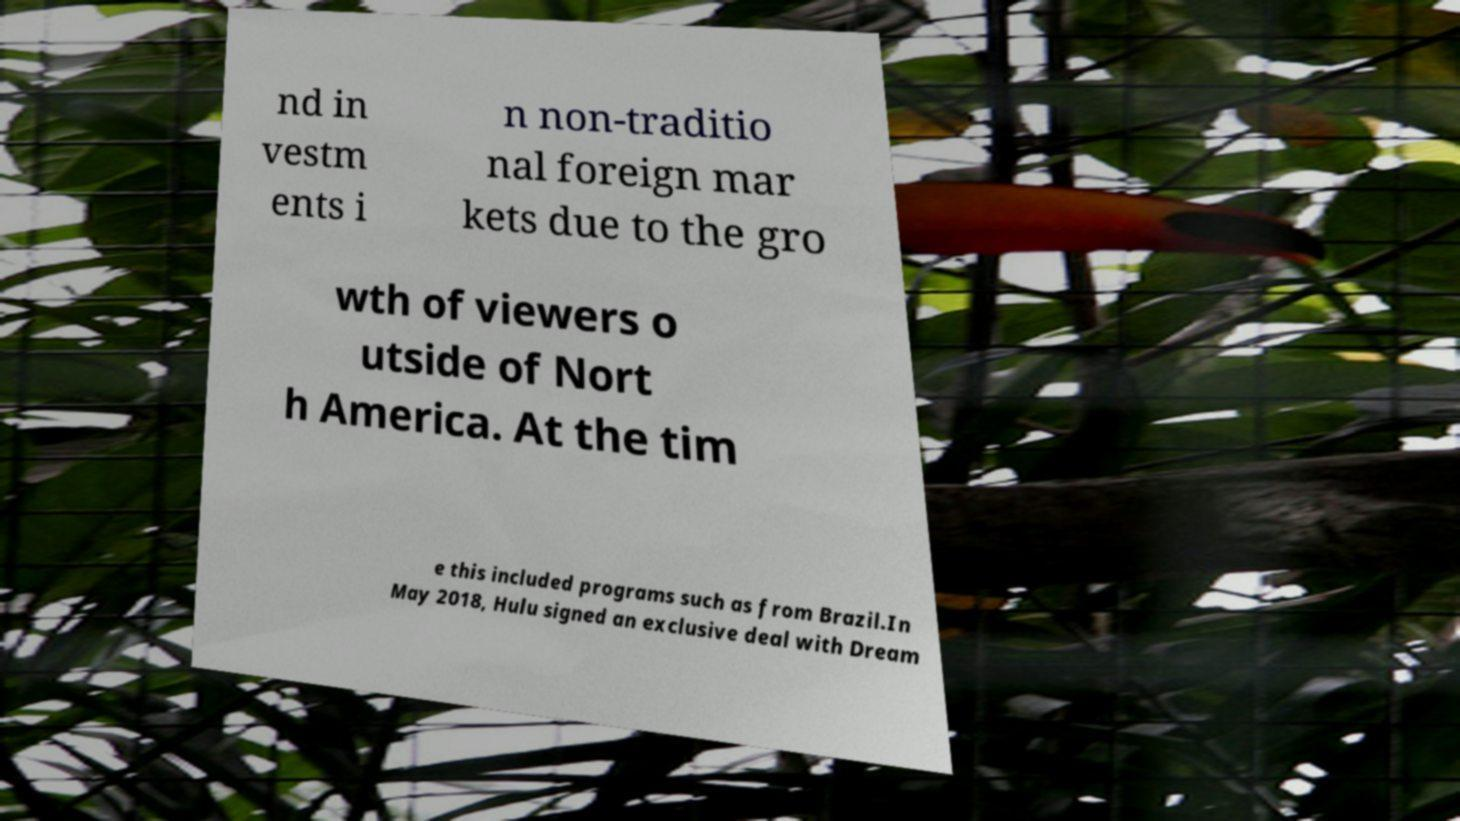Can you accurately transcribe the text from the provided image for me? nd in vestm ents i n non-traditio nal foreign mar kets due to the gro wth of viewers o utside of Nort h America. At the tim e this included programs such as from Brazil.In May 2018, Hulu signed an exclusive deal with Dream 